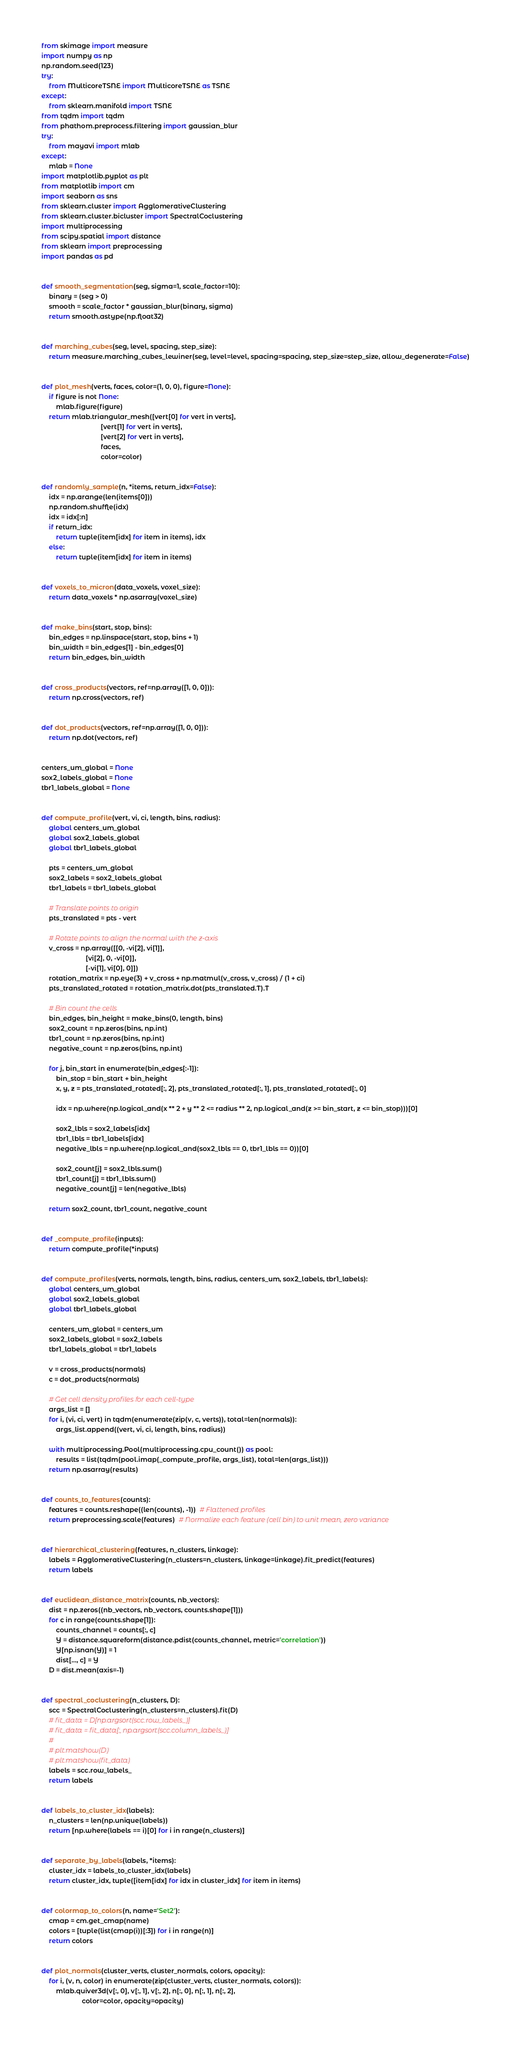<code> <loc_0><loc_0><loc_500><loc_500><_Python_>from skimage import measure
import numpy as np
np.random.seed(123)
try:
    from MulticoreTSNE import MulticoreTSNE as TSNE
except:
    from sklearn.manifold import TSNE
from tqdm import tqdm
from phathom.preprocess.filtering import gaussian_blur
try:
    from mayavi import mlab
except:
    mlab = None
import matplotlib.pyplot as plt
from matplotlib import cm
import seaborn as sns
from sklearn.cluster import AgglomerativeClustering
from sklearn.cluster.bicluster import SpectralCoclustering
import multiprocessing
from scipy.spatial import distance
from sklearn import preprocessing
import pandas as pd


def smooth_segmentation(seg, sigma=1, scale_factor=10):
    binary = (seg > 0)
    smooth = scale_factor * gaussian_blur(binary, sigma)
    return smooth.astype(np.float32)


def marching_cubes(seg, level, spacing, step_size):
    return measure.marching_cubes_lewiner(seg, level=level, spacing=spacing, step_size=step_size, allow_degenerate=False)


def plot_mesh(verts, faces, color=(1, 0, 0), figure=None):
    if figure is not None:
        mlab.figure(figure)
    return mlab.triangular_mesh([vert[0] for vert in verts],
                                [vert[1] for vert in verts],
                                [vert[2] for vert in verts],
                                faces,
                                color=color)


def randomly_sample(n, *items, return_idx=False):
    idx = np.arange(len(items[0]))
    np.random.shuffle(idx)
    idx = idx[:n]
    if return_idx:
        return tuple(item[idx] for item in items), idx
    else:
        return tuple(item[idx] for item in items)


def voxels_to_micron(data_voxels, voxel_size):
    return data_voxels * np.asarray(voxel_size)


def make_bins(start, stop, bins):
    bin_edges = np.linspace(start, stop, bins + 1)
    bin_width = bin_edges[1] - bin_edges[0]
    return bin_edges, bin_width


def cross_products(vectors, ref=np.array([1, 0, 0])):
    return np.cross(vectors, ref)


def dot_products(vectors, ref=np.array([1, 0, 0])):
    return np.dot(vectors, ref)


centers_um_global = None
sox2_labels_global = None
tbr1_labels_global = None


def compute_profile(vert, vi, ci, length, bins, radius):
    global centers_um_global
    global sox2_labels_global
    global tbr1_labels_global

    pts = centers_um_global
    sox2_labels = sox2_labels_global
    tbr1_labels = tbr1_labels_global

    # Translate points to origin
    pts_translated = pts - vert

    # Rotate points to align the normal with the z-axis
    v_cross = np.array([[0, -vi[2], vi[1]],
                        [vi[2], 0, -vi[0]],
                        [-vi[1], vi[0], 0]])
    rotation_matrix = np.eye(3) + v_cross + np.matmul(v_cross, v_cross) / (1 + ci)
    pts_translated_rotated = rotation_matrix.dot(pts_translated.T).T

    # Bin count the cells
    bin_edges, bin_height = make_bins(0, length, bins)
    sox2_count = np.zeros(bins, np.int)
    tbr1_count = np.zeros(bins, np.int)
    negative_count = np.zeros(bins, np.int)

    for j, bin_start in enumerate(bin_edges[:-1]):
        bin_stop = bin_start + bin_height
        x, y, z = pts_translated_rotated[:, 2], pts_translated_rotated[:, 1], pts_translated_rotated[:, 0]

        idx = np.where(np.logical_and(x ** 2 + y ** 2 <= radius ** 2, np.logical_and(z >= bin_start, z <= bin_stop)))[0]

        sox2_lbls = sox2_labels[idx]
        tbr1_lbls = tbr1_labels[idx]
        negative_lbls = np.where(np.logical_and(sox2_lbls == 0, tbr1_lbls == 0))[0]

        sox2_count[j] = sox2_lbls.sum()
        tbr1_count[j] = tbr1_lbls.sum()
        negative_count[j] = len(negative_lbls)

    return sox2_count, tbr1_count, negative_count


def _compute_profile(inputs):
    return compute_profile(*inputs)


def compute_profiles(verts, normals, length, bins, radius, centers_um, sox2_labels, tbr1_labels):
    global centers_um_global
    global sox2_labels_global
    global tbr1_labels_global

    centers_um_global = centers_um
    sox2_labels_global = sox2_labels
    tbr1_labels_global = tbr1_labels

    v = cross_products(normals)
    c = dot_products(normals)

    # Get cell density profiles for each cell-type
    args_list = []
    for i, (vi, ci, vert) in tqdm(enumerate(zip(v, c, verts)), total=len(normals)):
        args_list.append((vert, vi, ci, length, bins, radius))

    with multiprocessing.Pool(multiprocessing.cpu_count()) as pool:
        results = list(tqdm(pool.imap(_compute_profile, args_list), total=len(args_list)))
    return np.asarray(results)


def counts_to_features(counts):
    features = counts.reshape((len(counts), -1))  # Flattened profiles
    return preprocessing.scale(features)  # Normalize each feature (cell bin) to unit mean, zero variance


def hierarchical_clustering(features, n_clusters, linkage):
    labels = AgglomerativeClustering(n_clusters=n_clusters, linkage=linkage).fit_predict(features)
    return labels


def euclidean_distance_matrix(counts, nb_vectors):
    dist = np.zeros((nb_vectors, nb_vectors, counts.shape[1]))
    for c in range(counts.shape[1]):
        counts_channel = counts[:, c]
        Y = distance.squareform(distance.pdist(counts_channel, metric='correlation'))
        Y[np.isnan(Y)] = 1
        dist[..., c] = Y
    D = dist.mean(axis=-1)


def spectral_coclustering(n_clusters, D):
    scc = SpectralCoclustering(n_clusters=n_clusters).fit(D)
    # fit_data = D[np.argsort(scc.row_labels_)]
    # fit_data = fit_data[:, np.argsort(scc.column_labels_)]
    #
    # plt.matshow(D)
    # plt.matshow(fit_data)
    labels = scc.row_labels_
    return labels


def labels_to_cluster_idx(labels):
    n_clusters = len(np.unique(labels))
    return [np.where(labels == i)[0] for i in range(n_clusters)]


def separate_by_labels(labels, *items):
    cluster_idx = labels_to_cluster_idx(labels)
    return cluster_idx, tuple([item[idx] for idx in cluster_idx] for item in items)


def colormap_to_colors(n, name='Set2'):
    cmap = cm.get_cmap(name)
    colors = [tuple(list(cmap(i))[:3]) for i in range(n)]
    return colors


def plot_normals(cluster_verts, cluster_normals, colors, opacity):
    for i, (v, n, color) in enumerate(zip(cluster_verts, cluster_normals, colors)):
        mlab.quiver3d(v[:, 0], v[:, 1], v[:, 2], n[:, 0], n[:, 1], n[:, 2],
                      color=color, opacity=opacity)

</code> 